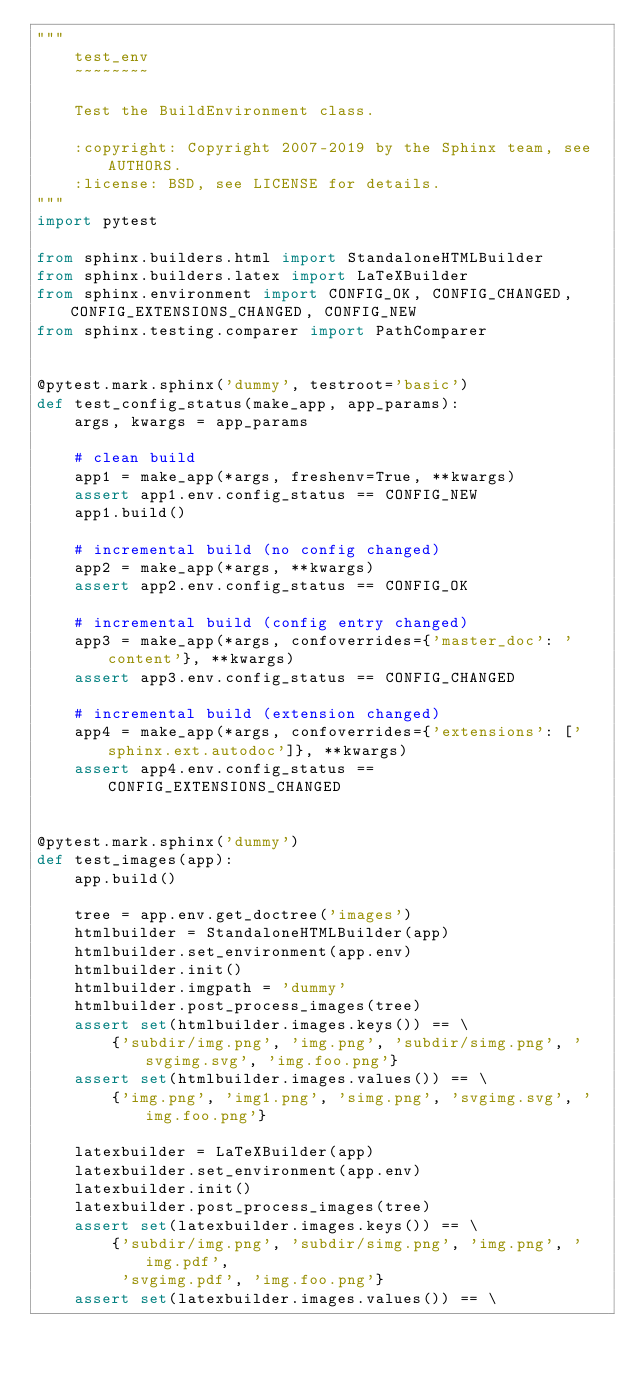Convert code to text. <code><loc_0><loc_0><loc_500><loc_500><_Python_>"""
    test_env
    ~~~~~~~~

    Test the BuildEnvironment class.

    :copyright: Copyright 2007-2019 by the Sphinx team, see AUTHORS.
    :license: BSD, see LICENSE for details.
"""
import pytest

from sphinx.builders.html import StandaloneHTMLBuilder
from sphinx.builders.latex import LaTeXBuilder
from sphinx.environment import CONFIG_OK, CONFIG_CHANGED, CONFIG_EXTENSIONS_CHANGED, CONFIG_NEW
from sphinx.testing.comparer import PathComparer


@pytest.mark.sphinx('dummy', testroot='basic')
def test_config_status(make_app, app_params):
    args, kwargs = app_params

    # clean build
    app1 = make_app(*args, freshenv=True, **kwargs)
    assert app1.env.config_status == CONFIG_NEW
    app1.build()

    # incremental build (no config changed)
    app2 = make_app(*args, **kwargs)
    assert app2.env.config_status == CONFIG_OK

    # incremental build (config entry changed)
    app3 = make_app(*args, confoverrides={'master_doc': 'content'}, **kwargs)
    assert app3.env.config_status == CONFIG_CHANGED

    # incremental build (extension changed)
    app4 = make_app(*args, confoverrides={'extensions': ['sphinx.ext.autodoc']}, **kwargs)
    assert app4.env.config_status == CONFIG_EXTENSIONS_CHANGED


@pytest.mark.sphinx('dummy')
def test_images(app):
    app.build()

    tree = app.env.get_doctree('images')
    htmlbuilder = StandaloneHTMLBuilder(app)
    htmlbuilder.set_environment(app.env)
    htmlbuilder.init()
    htmlbuilder.imgpath = 'dummy'
    htmlbuilder.post_process_images(tree)
    assert set(htmlbuilder.images.keys()) == \
        {'subdir/img.png', 'img.png', 'subdir/simg.png', 'svgimg.svg', 'img.foo.png'}
    assert set(htmlbuilder.images.values()) == \
        {'img.png', 'img1.png', 'simg.png', 'svgimg.svg', 'img.foo.png'}

    latexbuilder = LaTeXBuilder(app)
    latexbuilder.set_environment(app.env)
    latexbuilder.init()
    latexbuilder.post_process_images(tree)
    assert set(latexbuilder.images.keys()) == \
        {'subdir/img.png', 'subdir/simg.png', 'img.png', 'img.pdf',
         'svgimg.pdf', 'img.foo.png'}
    assert set(latexbuilder.images.values()) == \</code> 